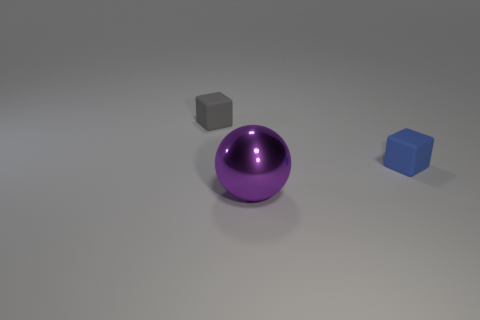Add 1 tiny green metal balls. How many objects exist? 4 Subtract all gray cubes. How many cubes are left? 1 Subtract 0 brown cylinders. How many objects are left? 3 Subtract all cubes. How many objects are left? 1 Subtract 1 blocks. How many blocks are left? 1 Subtract all yellow cubes. Subtract all blue cylinders. How many cubes are left? 2 Subtract all green blocks. How many yellow spheres are left? 0 Subtract all gray objects. Subtract all blue matte things. How many objects are left? 1 Add 1 blue blocks. How many blue blocks are left? 2 Add 3 gray rubber things. How many gray rubber things exist? 4 